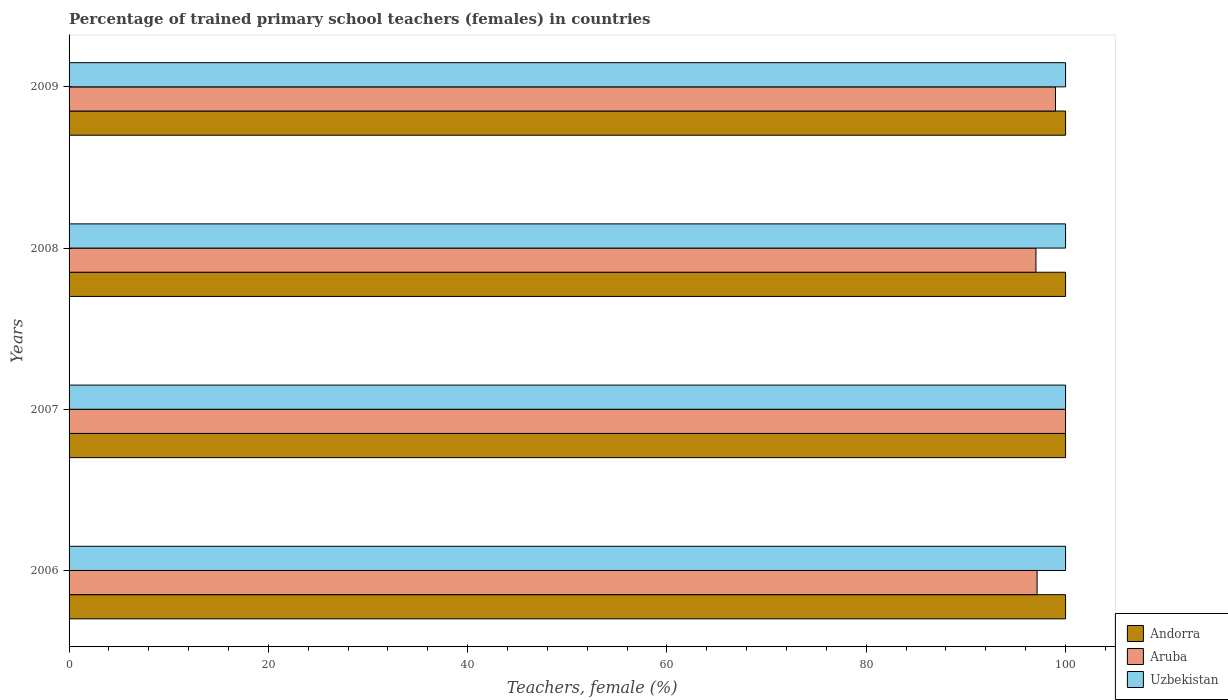In how many cases, is the number of bars for a given year not equal to the number of legend labels?
Offer a very short reply. 0. Across all years, what is the maximum percentage of trained primary school teachers (females) in Aruba?
Your response must be concise. 100. In which year was the percentage of trained primary school teachers (females) in Aruba minimum?
Provide a short and direct response. 2008. What is the difference between the percentage of trained primary school teachers (females) in Andorra in 2006 and that in 2007?
Provide a succinct answer. 0. What is the difference between the percentage of trained primary school teachers (females) in Aruba in 2009 and the percentage of trained primary school teachers (females) in Uzbekistan in 2007?
Offer a very short reply. -1.01. What is the average percentage of trained primary school teachers (females) in Uzbekistan per year?
Give a very brief answer. 100. In the year 2006, what is the difference between the percentage of trained primary school teachers (females) in Uzbekistan and percentage of trained primary school teachers (females) in Andorra?
Make the answer very short. 0. In how many years, is the percentage of trained primary school teachers (females) in Aruba greater than 40 %?
Ensure brevity in your answer.  4. What is the ratio of the percentage of trained primary school teachers (females) in Aruba in 2007 to that in 2009?
Your response must be concise. 1.01. Is the percentage of trained primary school teachers (females) in Aruba in 2008 less than that in 2009?
Your answer should be compact. Yes. Is the difference between the percentage of trained primary school teachers (females) in Uzbekistan in 2007 and 2009 greater than the difference between the percentage of trained primary school teachers (females) in Andorra in 2007 and 2009?
Your response must be concise. No. In how many years, is the percentage of trained primary school teachers (females) in Uzbekistan greater than the average percentage of trained primary school teachers (females) in Uzbekistan taken over all years?
Keep it short and to the point. 0. What does the 1st bar from the top in 2008 represents?
Offer a terse response. Uzbekistan. What does the 3rd bar from the bottom in 2006 represents?
Ensure brevity in your answer.  Uzbekistan. How many bars are there?
Keep it short and to the point. 12. Are all the bars in the graph horizontal?
Give a very brief answer. Yes. What is the difference between two consecutive major ticks on the X-axis?
Provide a short and direct response. 20. How are the legend labels stacked?
Your response must be concise. Vertical. What is the title of the graph?
Provide a short and direct response. Percentage of trained primary school teachers (females) in countries. What is the label or title of the X-axis?
Ensure brevity in your answer.  Teachers, female (%). What is the Teachers, female (%) of Aruba in 2006?
Offer a terse response. 97.14. What is the Teachers, female (%) in Uzbekistan in 2006?
Make the answer very short. 100. What is the Teachers, female (%) in Aruba in 2008?
Ensure brevity in your answer.  97.03. What is the Teachers, female (%) in Aruba in 2009?
Your response must be concise. 98.99. Across all years, what is the maximum Teachers, female (%) of Andorra?
Offer a terse response. 100. Across all years, what is the maximum Teachers, female (%) in Aruba?
Provide a succinct answer. 100. Across all years, what is the minimum Teachers, female (%) in Andorra?
Make the answer very short. 100. Across all years, what is the minimum Teachers, female (%) of Aruba?
Make the answer very short. 97.03. What is the total Teachers, female (%) of Andorra in the graph?
Your response must be concise. 400. What is the total Teachers, female (%) in Aruba in the graph?
Offer a terse response. 393.16. What is the difference between the Teachers, female (%) of Aruba in 2006 and that in 2007?
Offer a very short reply. -2.86. What is the difference between the Teachers, female (%) of Aruba in 2006 and that in 2008?
Provide a succinct answer. 0.11. What is the difference between the Teachers, female (%) of Andorra in 2006 and that in 2009?
Your response must be concise. 0. What is the difference between the Teachers, female (%) in Aruba in 2006 and that in 2009?
Provide a succinct answer. -1.85. What is the difference between the Teachers, female (%) of Andorra in 2007 and that in 2008?
Keep it short and to the point. 0. What is the difference between the Teachers, female (%) in Aruba in 2007 and that in 2008?
Offer a very short reply. 2.97. What is the difference between the Teachers, female (%) in Uzbekistan in 2007 and that in 2009?
Your answer should be very brief. 0. What is the difference between the Teachers, female (%) in Andorra in 2008 and that in 2009?
Ensure brevity in your answer.  0. What is the difference between the Teachers, female (%) of Aruba in 2008 and that in 2009?
Offer a terse response. -1.96. What is the difference between the Teachers, female (%) in Uzbekistan in 2008 and that in 2009?
Offer a terse response. 0. What is the difference between the Teachers, female (%) in Aruba in 2006 and the Teachers, female (%) in Uzbekistan in 2007?
Make the answer very short. -2.86. What is the difference between the Teachers, female (%) of Andorra in 2006 and the Teachers, female (%) of Aruba in 2008?
Your response must be concise. 2.97. What is the difference between the Teachers, female (%) in Andorra in 2006 and the Teachers, female (%) in Uzbekistan in 2008?
Offer a very short reply. 0. What is the difference between the Teachers, female (%) in Aruba in 2006 and the Teachers, female (%) in Uzbekistan in 2008?
Your response must be concise. -2.86. What is the difference between the Teachers, female (%) in Andorra in 2006 and the Teachers, female (%) in Aruba in 2009?
Your answer should be very brief. 1.01. What is the difference between the Teachers, female (%) of Andorra in 2006 and the Teachers, female (%) of Uzbekistan in 2009?
Keep it short and to the point. 0. What is the difference between the Teachers, female (%) of Aruba in 2006 and the Teachers, female (%) of Uzbekistan in 2009?
Ensure brevity in your answer.  -2.86. What is the difference between the Teachers, female (%) of Andorra in 2007 and the Teachers, female (%) of Aruba in 2008?
Keep it short and to the point. 2.97. What is the difference between the Teachers, female (%) in Andorra in 2008 and the Teachers, female (%) in Aruba in 2009?
Your answer should be compact. 1.01. What is the difference between the Teachers, female (%) of Andorra in 2008 and the Teachers, female (%) of Uzbekistan in 2009?
Ensure brevity in your answer.  0. What is the difference between the Teachers, female (%) of Aruba in 2008 and the Teachers, female (%) of Uzbekistan in 2009?
Your answer should be compact. -2.97. What is the average Teachers, female (%) of Andorra per year?
Offer a terse response. 100. What is the average Teachers, female (%) of Aruba per year?
Provide a succinct answer. 98.29. What is the average Teachers, female (%) in Uzbekistan per year?
Make the answer very short. 100. In the year 2006, what is the difference between the Teachers, female (%) of Andorra and Teachers, female (%) of Aruba?
Make the answer very short. 2.86. In the year 2006, what is the difference between the Teachers, female (%) in Andorra and Teachers, female (%) in Uzbekistan?
Your answer should be very brief. 0. In the year 2006, what is the difference between the Teachers, female (%) of Aruba and Teachers, female (%) of Uzbekistan?
Your answer should be very brief. -2.86. In the year 2007, what is the difference between the Teachers, female (%) in Andorra and Teachers, female (%) in Aruba?
Give a very brief answer. 0. In the year 2007, what is the difference between the Teachers, female (%) of Andorra and Teachers, female (%) of Uzbekistan?
Your response must be concise. 0. In the year 2007, what is the difference between the Teachers, female (%) in Aruba and Teachers, female (%) in Uzbekistan?
Provide a short and direct response. 0. In the year 2008, what is the difference between the Teachers, female (%) in Andorra and Teachers, female (%) in Aruba?
Your answer should be very brief. 2.97. In the year 2008, what is the difference between the Teachers, female (%) in Aruba and Teachers, female (%) in Uzbekistan?
Your response must be concise. -2.97. In the year 2009, what is the difference between the Teachers, female (%) in Andorra and Teachers, female (%) in Aruba?
Keep it short and to the point. 1.01. In the year 2009, what is the difference between the Teachers, female (%) of Aruba and Teachers, female (%) of Uzbekistan?
Offer a very short reply. -1.01. What is the ratio of the Teachers, female (%) of Andorra in 2006 to that in 2007?
Offer a terse response. 1. What is the ratio of the Teachers, female (%) of Aruba in 2006 to that in 2007?
Keep it short and to the point. 0.97. What is the ratio of the Teachers, female (%) in Aruba in 2006 to that in 2008?
Ensure brevity in your answer.  1. What is the ratio of the Teachers, female (%) in Uzbekistan in 2006 to that in 2008?
Offer a terse response. 1. What is the ratio of the Teachers, female (%) of Aruba in 2006 to that in 2009?
Provide a short and direct response. 0.98. What is the ratio of the Teachers, female (%) of Uzbekistan in 2006 to that in 2009?
Offer a terse response. 1. What is the ratio of the Teachers, female (%) of Aruba in 2007 to that in 2008?
Keep it short and to the point. 1.03. What is the ratio of the Teachers, female (%) of Aruba in 2007 to that in 2009?
Offer a terse response. 1.01. What is the ratio of the Teachers, female (%) in Aruba in 2008 to that in 2009?
Provide a short and direct response. 0.98. What is the ratio of the Teachers, female (%) of Uzbekistan in 2008 to that in 2009?
Your answer should be compact. 1. What is the difference between the highest and the second highest Teachers, female (%) of Andorra?
Ensure brevity in your answer.  0. What is the difference between the highest and the second highest Teachers, female (%) in Aruba?
Provide a succinct answer. 1.01. What is the difference between the highest and the second highest Teachers, female (%) in Uzbekistan?
Ensure brevity in your answer.  0. What is the difference between the highest and the lowest Teachers, female (%) in Aruba?
Make the answer very short. 2.97. What is the difference between the highest and the lowest Teachers, female (%) of Uzbekistan?
Provide a short and direct response. 0. 